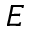<formula> <loc_0><loc_0><loc_500><loc_500>E</formula> 